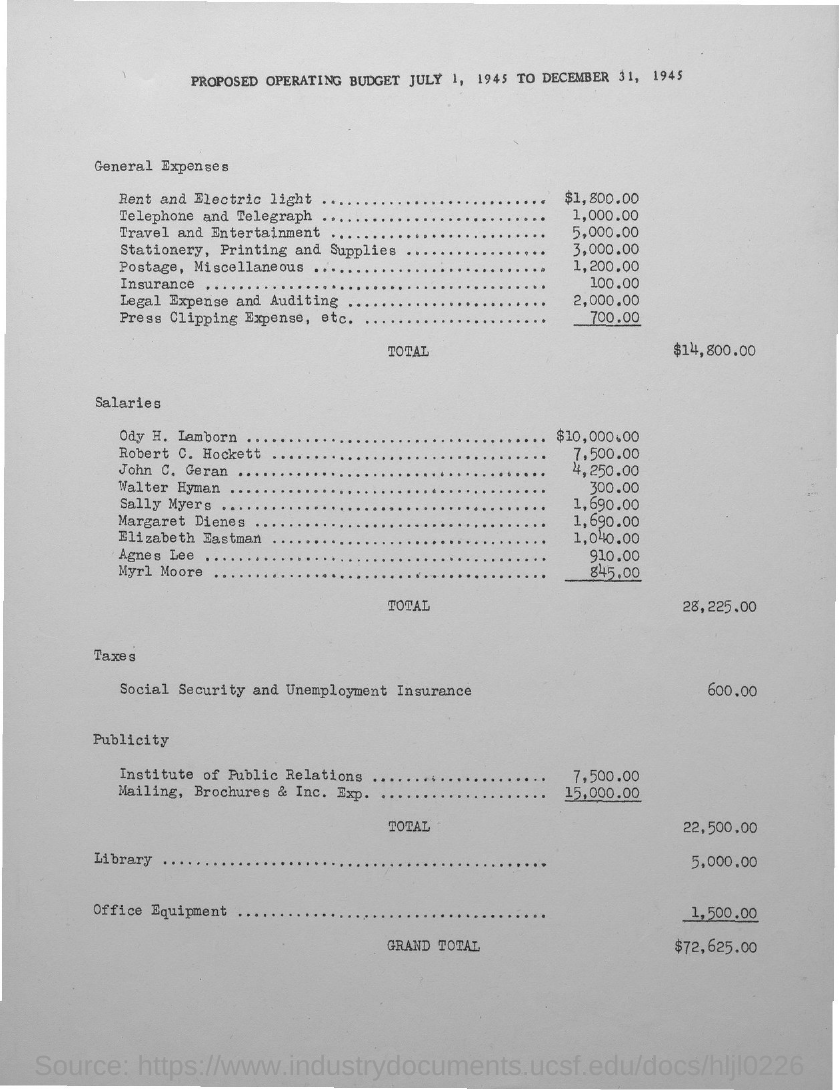What is the total salary?
Your answer should be very brief. 28,225.00. What is the total General Expense?
Your response must be concise. $14,800.00. 